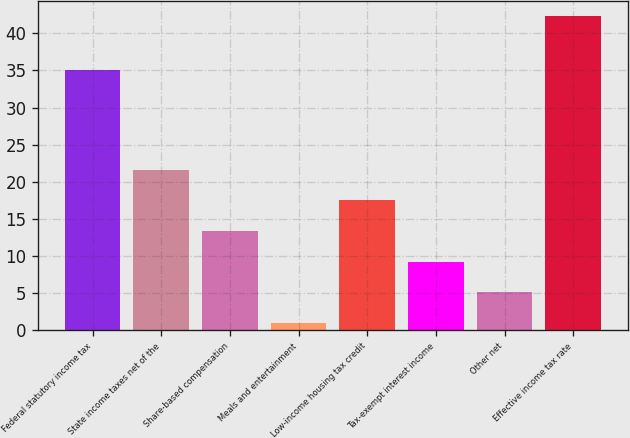<chart> <loc_0><loc_0><loc_500><loc_500><bar_chart><fcel>Federal statutory income tax<fcel>State income taxes net of the<fcel>Share-based compensation<fcel>Meals and entertainment<fcel>Low-income housing tax credit<fcel>Tax-exempt interest income<fcel>Other net<fcel>Effective income tax rate<nl><fcel>35<fcel>21.6<fcel>13.32<fcel>0.9<fcel>17.46<fcel>9.18<fcel>5.04<fcel>42.3<nl></chart> 